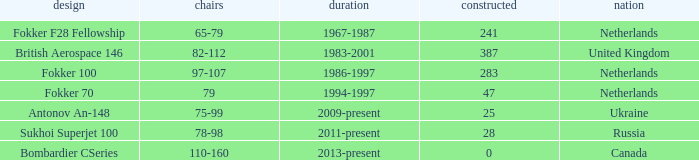Between which years were there 241 fokker 70 model cabins built? 1994-1997. 